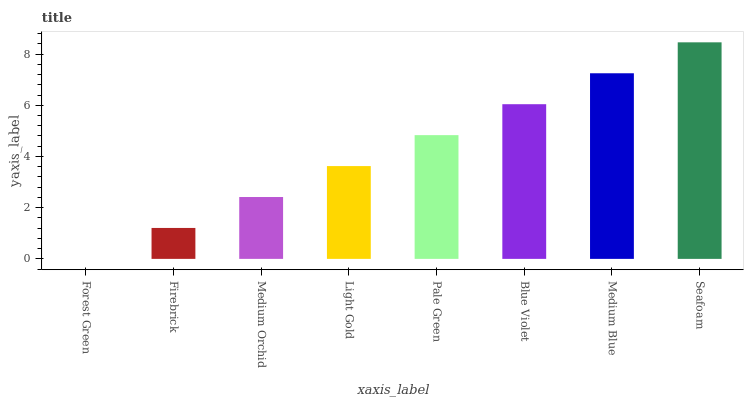Is Forest Green the minimum?
Answer yes or no. Yes. Is Seafoam the maximum?
Answer yes or no. Yes. Is Firebrick the minimum?
Answer yes or no. No. Is Firebrick the maximum?
Answer yes or no. No. Is Firebrick greater than Forest Green?
Answer yes or no. Yes. Is Forest Green less than Firebrick?
Answer yes or no. Yes. Is Forest Green greater than Firebrick?
Answer yes or no. No. Is Firebrick less than Forest Green?
Answer yes or no. No. Is Pale Green the high median?
Answer yes or no. Yes. Is Light Gold the low median?
Answer yes or no. Yes. Is Light Gold the high median?
Answer yes or no. No. Is Seafoam the low median?
Answer yes or no. No. 